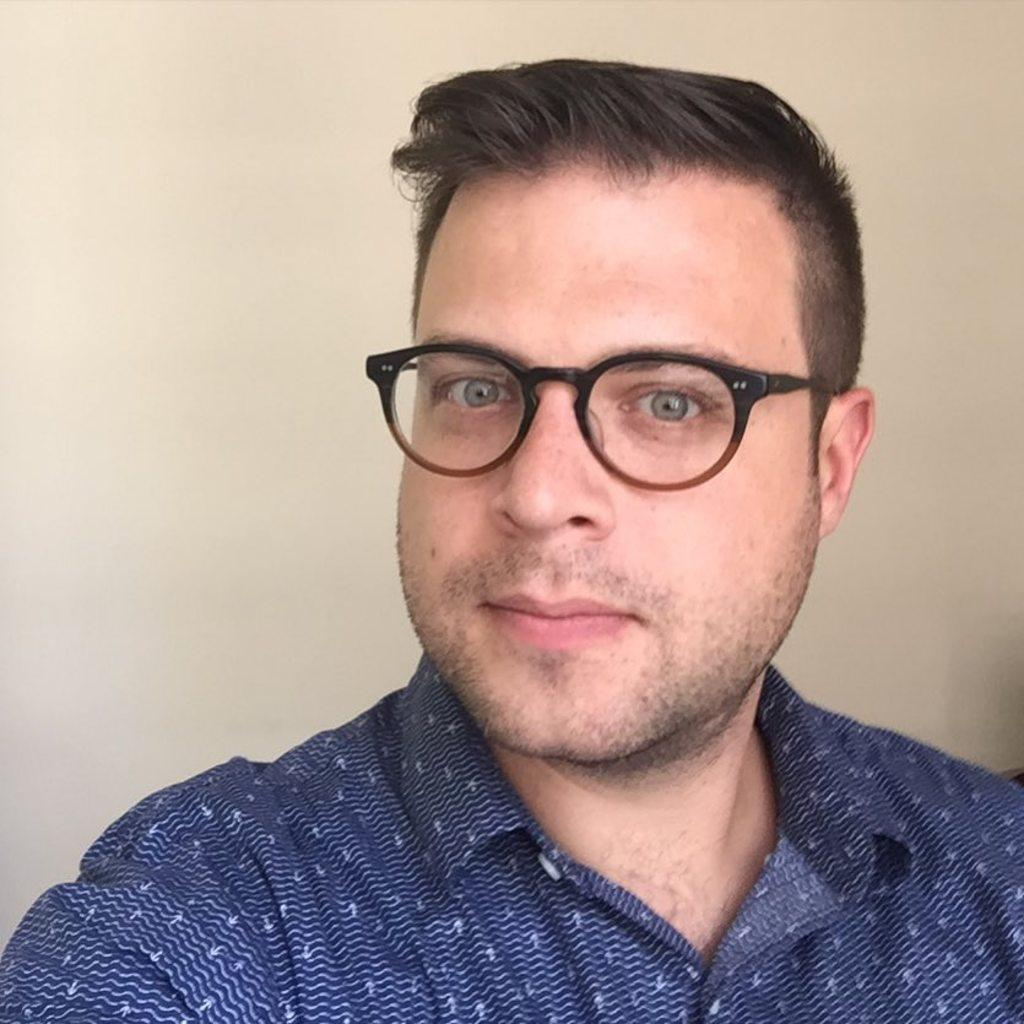Who is present in the image? There is a man in the image. What is the man wearing on his face? The man is wearing spectacles. What type of clothing is the man wearing on his upper body? The man is wearing a t-shirt. What color is the wall visible in the background of the image? There is a white-colored wall in the background of the image. What is the name of the person touching the wall in the image? There is no person touching the wall in the image. 